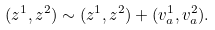Convert formula to latex. <formula><loc_0><loc_0><loc_500><loc_500>( z ^ { 1 } , z ^ { 2 } ) \sim ( z ^ { 1 } , z ^ { 2 } ) + ( v _ { a } ^ { 1 } , v _ { a } ^ { 2 } ) .</formula> 